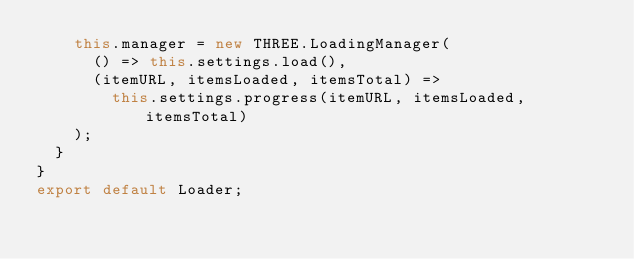Convert code to text. <code><loc_0><loc_0><loc_500><loc_500><_JavaScript_>    this.manager = new THREE.LoadingManager(
      () => this.settings.load(),
      (itemURL, itemsLoaded, itemsTotal) =>
        this.settings.progress(itemURL, itemsLoaded, itemsTotal)
    );
  }
}
export default Loader;
</code> 